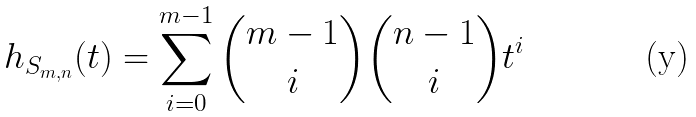<formula> <loc_0><loc_0><loc_500><loc_500>h _ { S _ { m , n } } ( t ) = \sum _ { i = 0 } ^ { m - 1 } \binom { m - 1 } { i } \binom { n - 1 } { i } t ^ { i }</formula> 